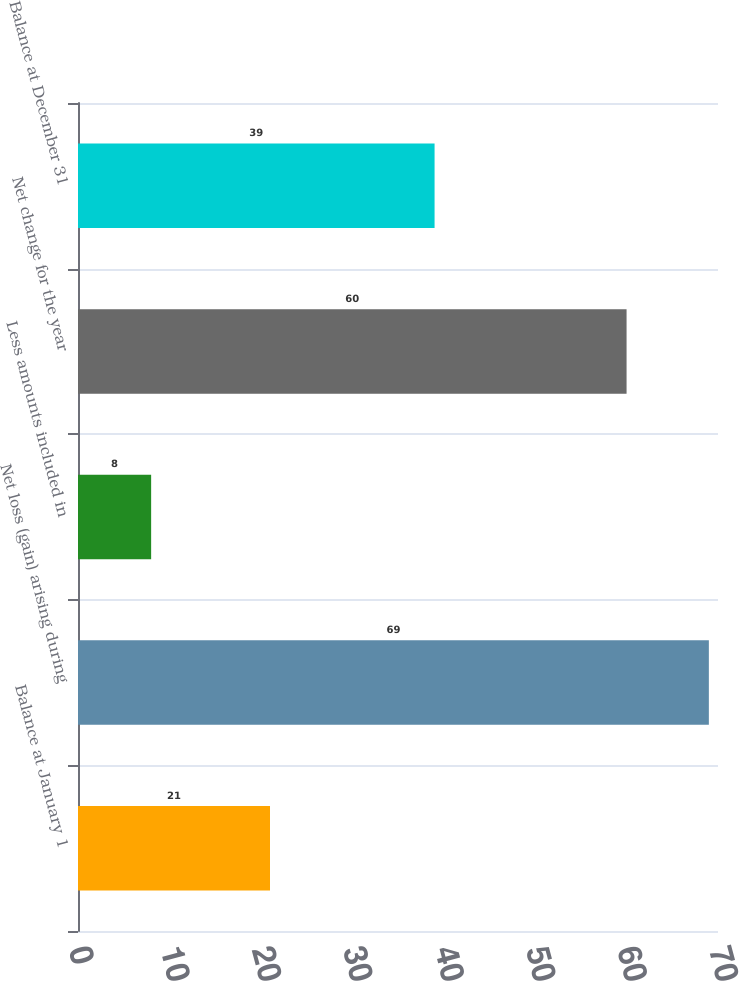Convert chart to OTSL. <chart><loc_0><loc_0><loc_500><loc_500><bar_chart><fcel>Balance at January 1<fcel>Net loss (gain) arising during<fcel>Less amounts included in<fcel>Net change for the year<fcel>Balance at December 31<nl><fcel>21<fcel>69<fcel>8<fcel>60<fcel>39<nl></chart> 